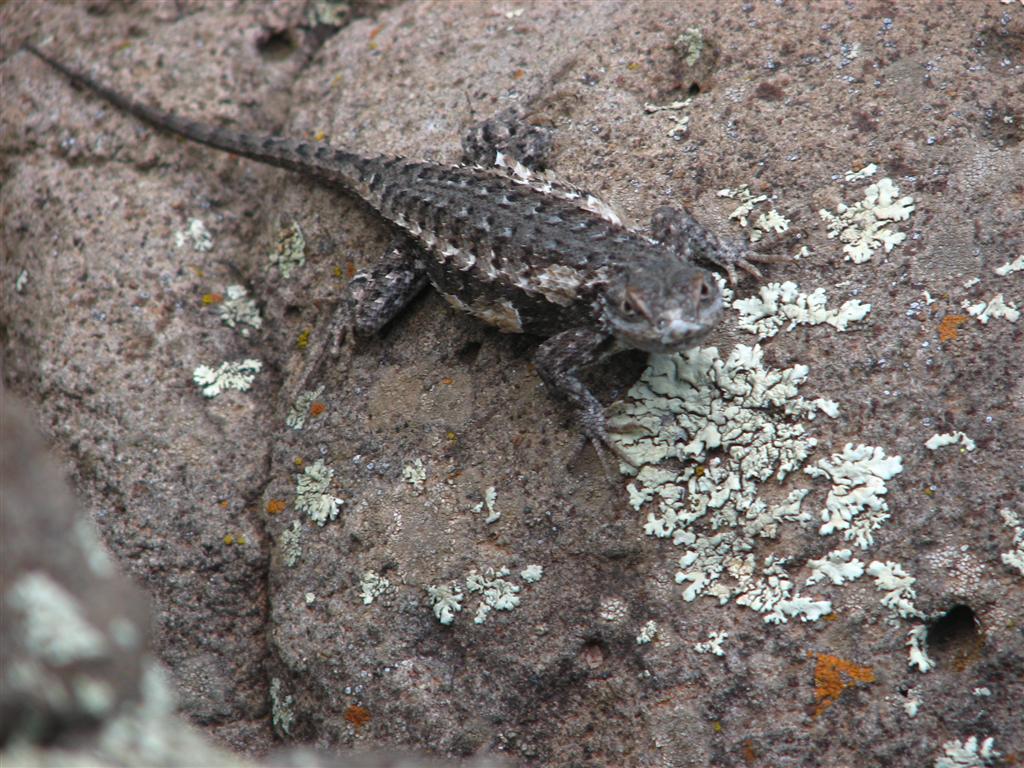How would you summarize this image in a sentence or two? In this picture we can see a lizard on a surface. 